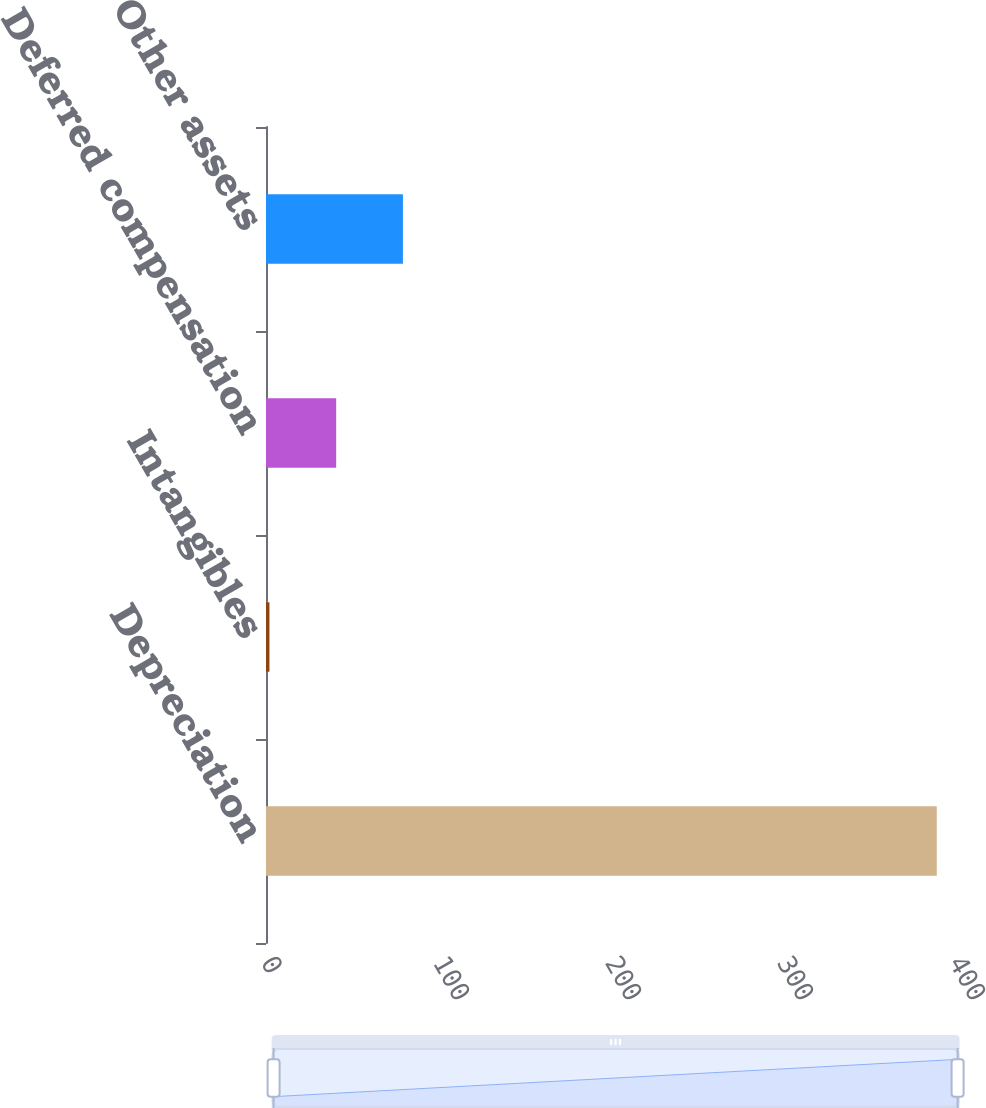Convert chart to OTSL. <chart><loc_0><loc_0><loc_500><loc_500><bar_chart><fcel>Depreciation<fcel>Intangibles<fcel>Deferred compensation<fcel>Other assets<nl><fcel>390<fcel>2<fcel>40.8<fcel>79.6<nl></chart> 